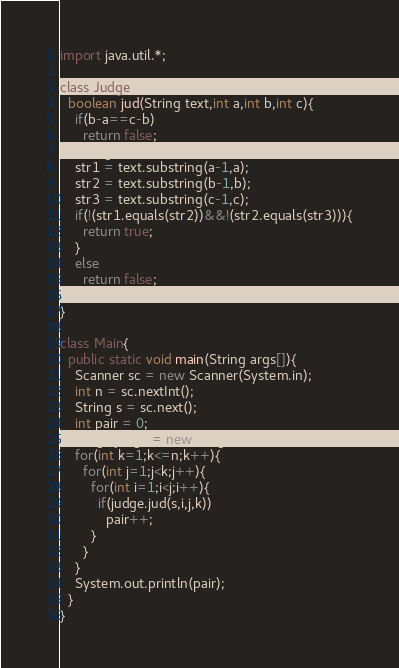Convert code to text. <code><loc_0><loc_0><loc_500><loc_500><_Java_>import java.util.*;

class Judge{
  boolean jud(String text,int a,int b,int c){
    if(b-a==c-b)
      return false;
    String str1,str2,str3;
    str1 = text.substring(a-1,a);
    str2 = text.substring(b-1,b);
    str3 = text.substring(c-1,c);
    if(!(str1.equals(str2))&&!(str2.equals(str3))){
      return true;
    }
    else
      return false;
  }
}

class Main{
  public static void main(String args[]){
    Scanner sc = new Scanner(System.in);
    int n = sc.nextInt();
    String s = sc.next();
    int pair = 0;
    Judge judge = new Judge();
    for(int k=1;k<=n;k++){
      for(int j=1;j<k;j++){
        for(int i=1;i<j;i++){
          if(judge.jud(s,i,j,k))
            pair++;
        }
      }
    }
    System.out.println(pair);
  }
}</code> 